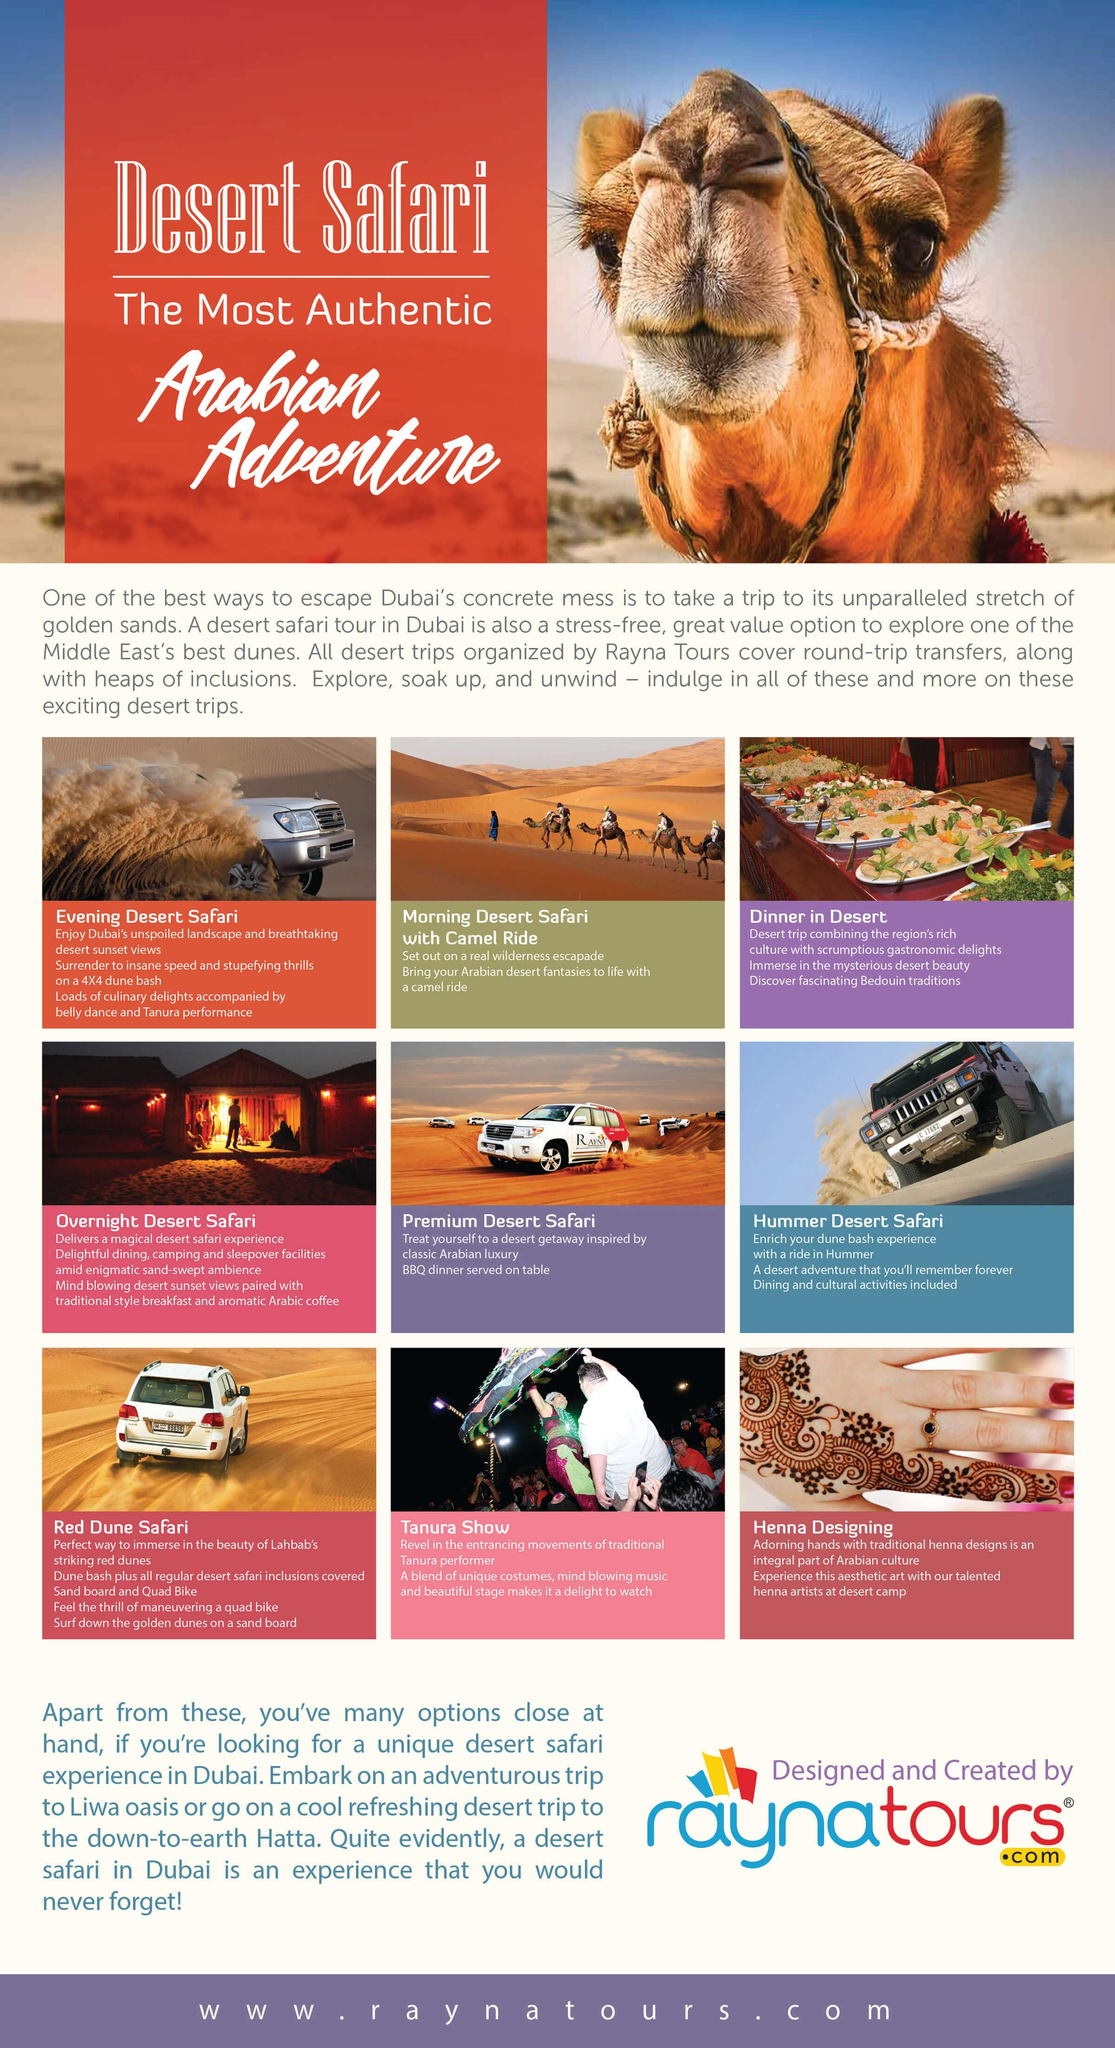Identify some key points in this picture. During a premium desert safari, a barbecue dinner was served on a table in the safari. The brochure includes other activities besides Safari, such as Dinner in the Desert, Tanura Show, and Henna Designing. As depicted in the image, the overnight desert safari offers sleepover facilities in either a tent or a flat arrangement. Red Dune Safari is arranged in Lahbab. There are six types of Desert Safari that have been mentioned. 